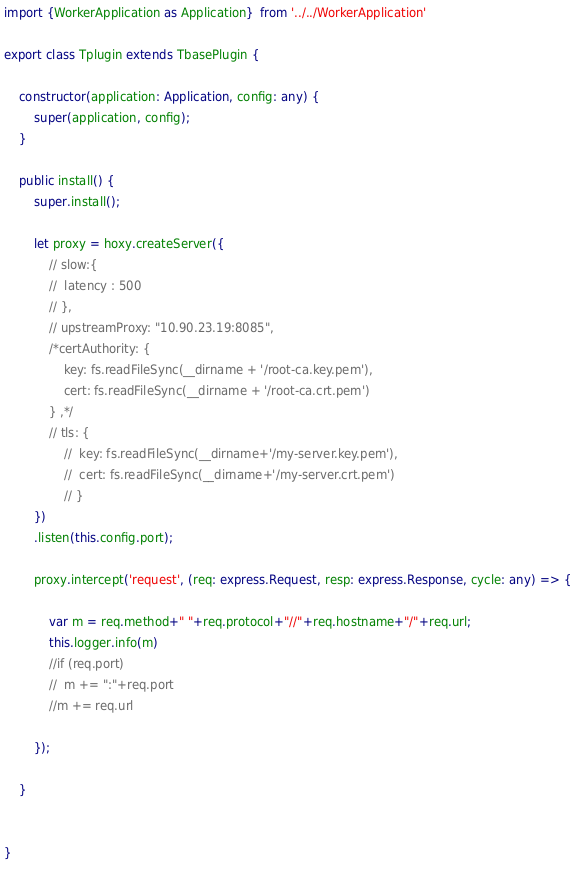Convert code to text. <code><loc_0><loc_0><loc_500><loc_500><_TypeScript_>import {WorkerApplication as Application}  from '../../WorkerApplication'

export class Tplugin extends TbasePlugin {

	constructor(application: Application, config: any) {
		super(application, config);
	}

	public install() {
		super.install();

		let proxy = hoxy.createServer({
			// slow:{
			// 	latency : 500
			// },
			// upstreamProxy: "10.90.23.19:8085",
			/*certAuthority: {
				key: fs.readFileSync(__dirname + '/root-ca.key.pem'),
				cert: fs.readFileSync(__dirname + '/root-ca.crt.pem')
			} ,*/
			// tls: {
				// 	key: fs.readFileSync(__dirname+'/my-server.key.pem'),
				// 	cert: fs.readFileSync(__dirname+'/my-server.crt.pem')
				// }
		})
		.listen(this.config.port);

		proxy.intercept('request', (req: express.Request, resp: express.Response, cycle: any) => {

			var m = req.method+" "+req.protocol+"//"+req.hostname+"/"+req.url;
			this.logger.info(m)
			//if (req.port)
			//	m += ":"+req.port
			//m += req.url

		});

	}


}


</code> 